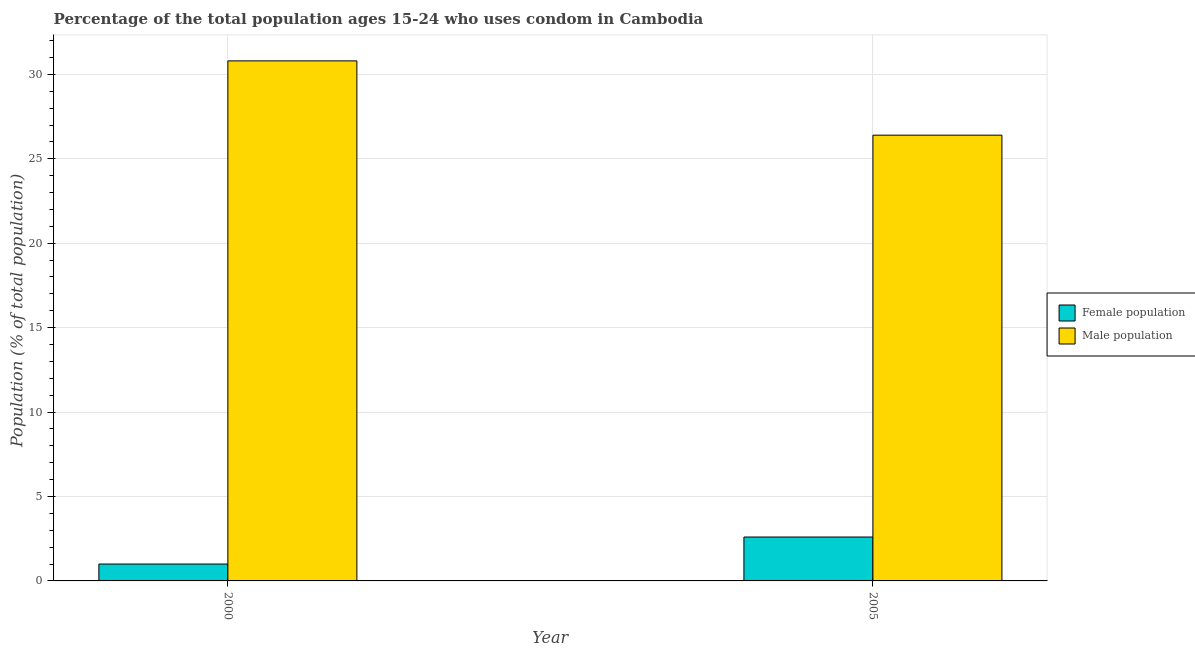How many groups of bars are there?
Provide a succinct answer. 2. Are the number of bars per tick equal to the number of legend labels?
Give a very brief answer. Yes. How many bars are there on the 2nd tick from the right?
Provide a short and direct response. 2. What is the female population in 2005?
Give a very brief answer. 2.6. Across all years, what is the maximum female population?
Ensure brevity in your answer.  2.6. Across all years, what is the minimum female population?
Give a very brief answer. 1. In which year was the female population maximum?
Your answer should be very brief. 2005. What is the difference between the female population in 2000 and that in 2005?
Offer a very short reply. -1.6. What is the difference between the male population in 2005 and the female population in 2000?
Your response must be concise. -4.4. What is the average male population per year?
Give a very brief answer. 28.6. In the year 2000, what is the difference between the female population and male population?
Your answer should be compact. 0. In how many years, is the male population greater than 5 %?
Make the answer very short. 2. What is the ratio of the female population in 2000 to that in 2005?
Your response must be concise. 0.38. What does the 2nd bar from the left in 2000 represents?
Provide a short and direct response. Male population. What does the 1st bar from the right in 2000 represents?
Your answer should be compact. Male population. How many bars are there?
Your answer should be compact. 4. Are all the bars in the graph horizontal?
Your response must be concise. No. How many years are there in the graph?
Give a very brief answer. 2. What is the difference between two consecutive major ticks on the Y-axis?
Make the answer very short. 5. Are the values on the major ticks of Y-axis written in scientific E-notation?
Offer a very short reply. No. Does the graph contain any zero values?
Ensure brevity in your answer.  No. Where does the legend appear in the graph?
Provide a short and direct response. Center right. What is the title of the graph?
Your response must be concise. Percentage of the total population ages 15-24 who uses condom in Cambodia. Does "Register a property" appear as one of the legend labels in the graph?
Your response must be concise. No. What is the label or title of the X-axis?
Provide a succinct answer. Year. What is the label or title of the Y-axis?
Offer a very short reply. Population (% of total population) . What is the Population (% of total population)  in Female population in 2000?
Make the answer very short. 1. What is the Population (% of total population)  of Male population in 2000?
Offer a very short reply. 30.8. What is the Population (% of total population)  in Female population in 2005?
Offer a terse response. 2.6. What is the Population (% of total population)  of Male population in 2005?
Offer a terse response. 26.4. Across all years, what is the maximum Population (% of total population)  of Male population?
Offer a terse response. 30.8. Across all years, what is the minimum Population (% of total population)  of Male population?
Provide a succinct answer. 26.4. What is the total Population (% of total population)  of Male population in the graph?
Your answer should be very brief. 57.2. What is the difference between the Population (% of total population)  in Female population in 2000 and that in 2005?
Give a very brief answer. -1.6. What is the difference between the Population (% of total population)  of Female population in 2000 and the Population (% of total population)  of Male population in 2005?
Make the answer very short. -25.4. What is the average Population (% of total population)  of Female population per year?
Give a very brief answer. 1.8. What is the average Population (% of total population)  in Male population per year?
Provide a succinct answer. 28.6. In the year 2000, what is the difference between the Population (% of total population)  in Female population and Population (% of total population)  in Male population?
Make the answer very short. -29.8. In the year 2005, what is the difference between the Population (% of total population)  in Female population and Population (% of total population)  in Male population?
Your answer should be very brief. -23.8. What is the ratio of the Population (% of total population)  in Female population in 2000 to that in 2005?
Your answer should be very brief. 0.38. What is the difference between the highest and the lowest Population (% of total population)  in Male population?
Your answer should be compact. 4.4. 